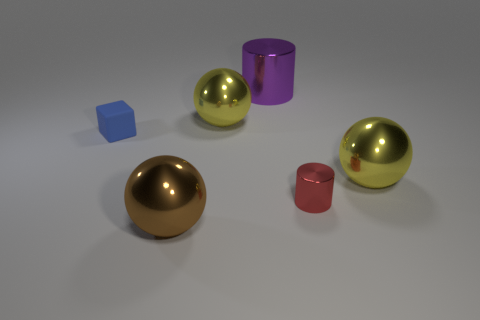There is a tiny matte thing; is its color the same as the tiny metallic thing that is on the right side of the small blue rubber cube?
Your response must be concise. No. What size is the brown sphere that is made of the same material as the red thing?
Ensure brevity in your answer.  Large. Are there any other things that have the same color as the matte object?
Offer a terse response. No. What number of things are cylinders that are behind the small rubber block or small red metal things?
Keep it short and to the point. 2. Is the purple object made of the same material as the tiny object on the right side of the brown shiny sphere?
Keep it short and to the point. Yes. Are there any large spheres that have the same material as the red cylinder?
Give a very brief answer. Yes. What number of objects are either big yellow metallic spheres that are on the right side of the large metal cylinder or large metal spheres that are behind the brown metal ball?
Ensure brevity in your answer.  2. Is the shape of the blue matte object the same as the big thing that is in front of the red metal object?
Provide a succinct answer. No. How many other objects are there of the same shape as the big brown object?
Make the answer very short. 2. How many things are small red metal cylinders or small purple shiny balls?
Offer a very short reply. 1. 